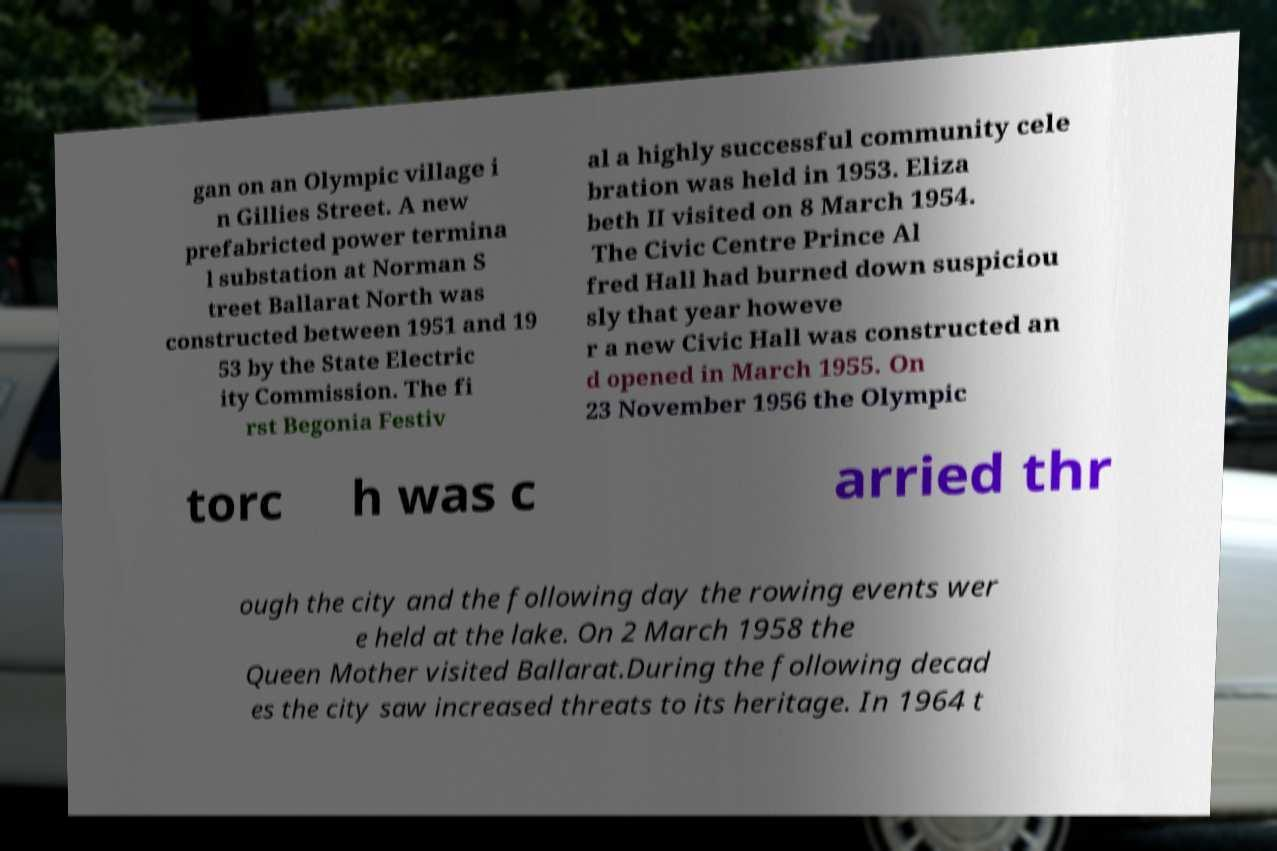I need the written content from this picture converted into text. Can you do that? gan on an Olympic village i n Gillies Street. A new prefabricted power termina l substation at Norman S treet Ballarat North was constructed between 1951 and 19 53 by the State Electric ity Commission. The fi rst Begonia Festiv al a highly successful community cele bration was held in 1953. Eliza beth II visited on 8 March 1954. The Civic Centre Prince Al fred Hall had burned down suspiciou sly that year howeve r a new Civic Hall was constructed an d opened in March 1955. On 23 November 1956 the Olympic torc h was c arried thr ough the city and the following day the rowing events wer e held at the lake. On 2 March 1958 the Queen Mother visited Ballarat.During the following decad es the city saw increased threats to its heritage. In 1964 t 